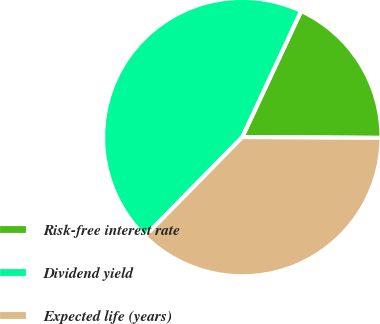Convert chart to OTSL. <chart><loc_0><loc_0><loc_500><loc_500><pie_chart><fcel>Risk-free interest rate<fcel>Dividend yield<fcel>Expected life (years)<nl><fcel>18.15%<fcel>44.6%<fcel>37.25%<nl></chart> 